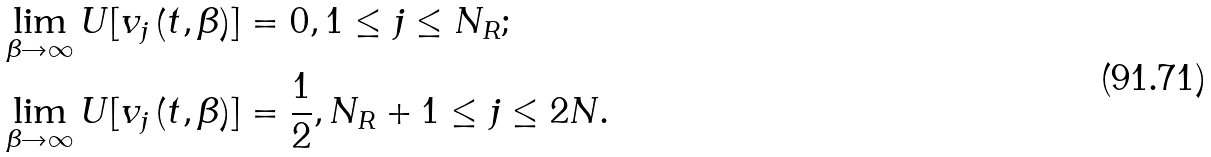<formula> <loc_0><loc_0><loc_500><loc_500>& \lim _ { \beta \rightarrow \infty } U [ v _ { j } \left ( t , \beta \right ) ] = 0 , 1 \leq j \leq N _ { R } ; \\ & \lim _ { \beta \rightarrow \infty } U [ v _ { j } \left ( t , \beta \right ) ] = \frac { 1 } { 2 } , N _ { R } + 1 \leq j \leq 2 N .</formula> 